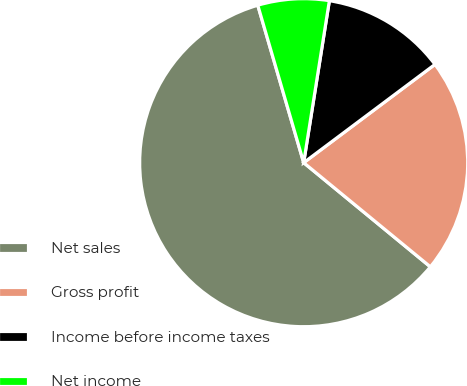Convert chart to OTSL. <chart><loc_0><loc_0><loc_500><loc_500><pie_chart><fcel>Net sales<fcel>Gross profit<fcel>Income before income taxes<fcel>Net income<nl><fcel>59.54%<fcel>21.18%<fcel>12.27%<fcel>7.02%<nl></chart> 